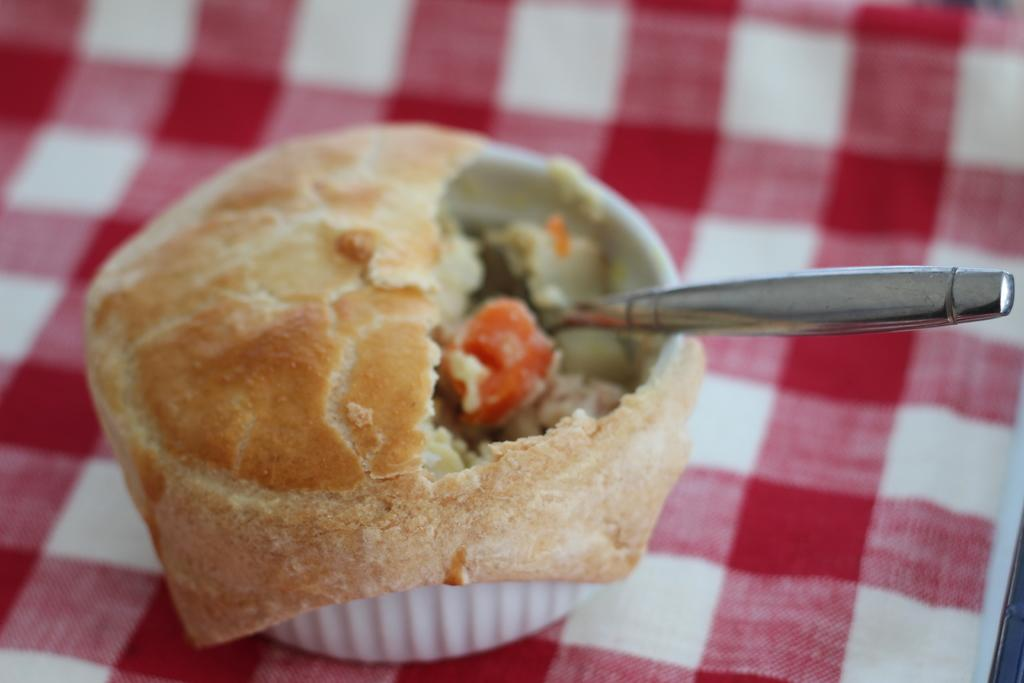What is the main object in the image? There is a food item in the image. What utensil is present in the image? There is a spoon in the image. Where are the food item and spoon located? The food item and spoon are in a cup. What is the cup placed on? The cup is placed on a cloth. Can you describe the pattern on the cloth? The cloth has red and white color boxes on it. How does the police officer interact with the lettuce in the image? There is no police officer or lettuce present in the image. 